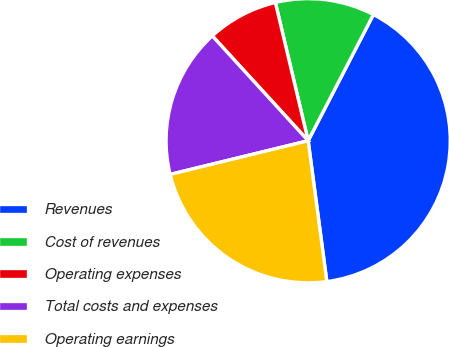<chart> <loc_0><loc_0><loc_500><loc_500><pie_chart><fcel>Revenues<fcel>Cost of revenues<fcel>Operating expenses<fcel>Total costs and expenses<fcel>Operating earnings<nl><fcel>40.31%<fcel>11.3%<fcel>8.08%<fcel>17.02%<fcel>23.29%<nl></chart> 